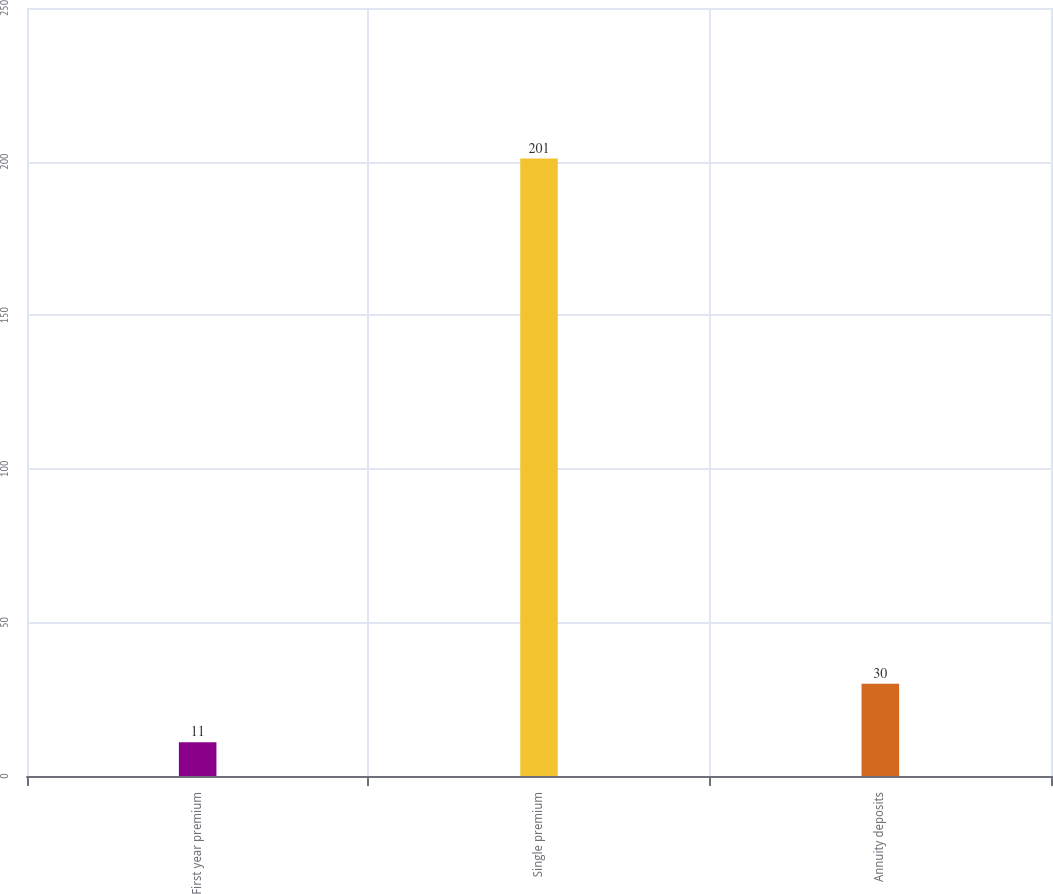Convert chart. <chart><loc_0><loc_0><loc_500><loc_500><bar_chart><fcel>First year premium<fcel>Single premium<fcel>Annuity deposits<nl><fcel>11<fcel>201<fcel>30<nl></chart> 